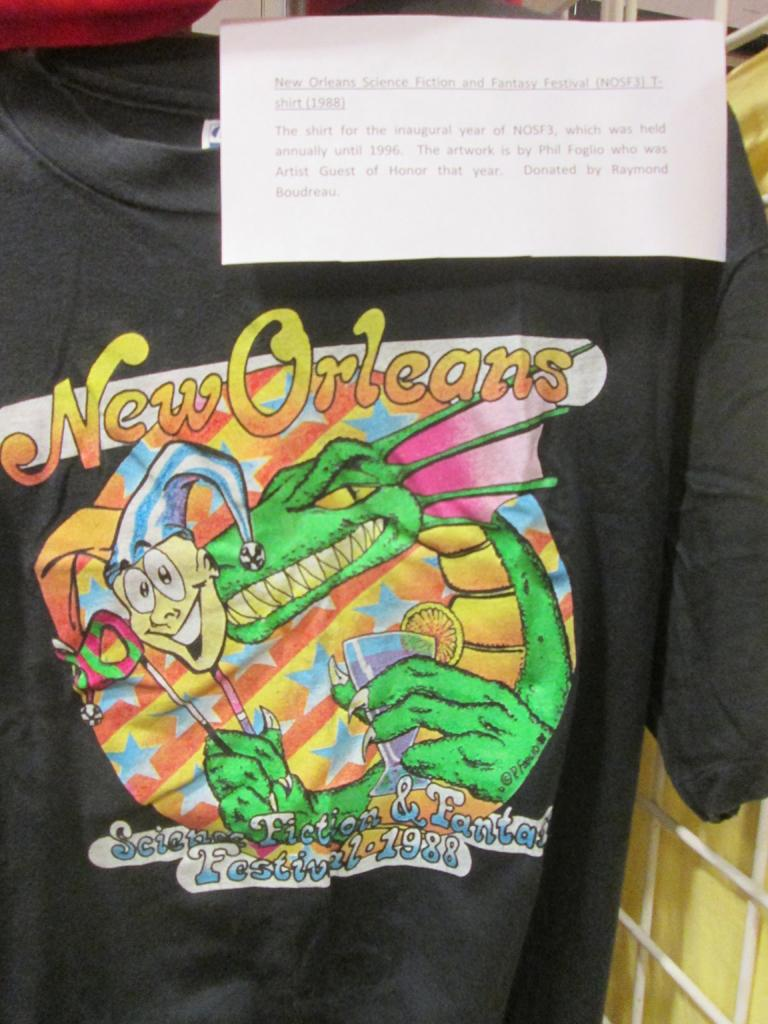What is hanging on the hanger in the image? There is a t-shirt on a hanger in the image. What can be seen on the t-shirt? The t-shirt has pictures and text on it. What type of object is visible in the image, made of metal? There is a metal grill in the image. What is the paper with text on it used for in the image? The paper with text on it might be used for writing or reading. What type of bone can be seen in the image? There is no bone present in the image. What type of flesh is visible on the t-shirt in the image? There is no flesh visible on the t-shirt in the image; it is a piece of clothing with pictures and text. 